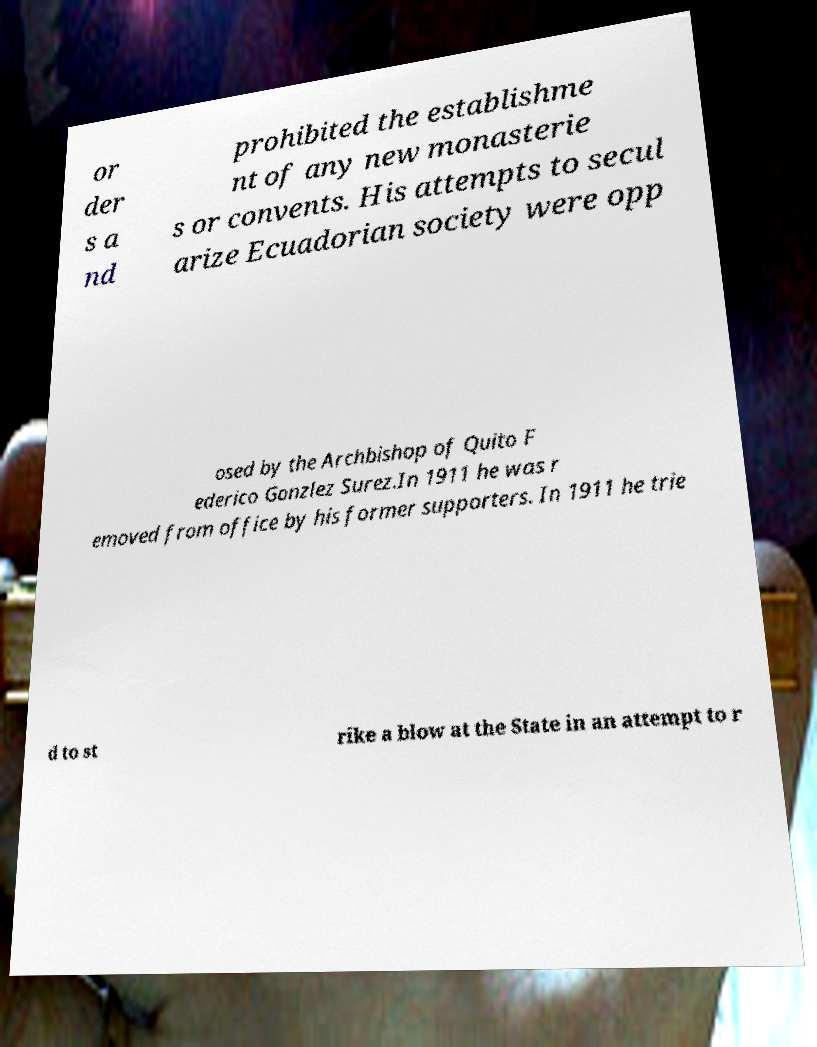What messages or text are displayed in this image? I need them in a readable, typed format. or der s a nd prohibited the establishme nt of any new monasterie s or convents. His attempts to secul arize Ecuadorian society were opp osed by the Archbishop of Quito F ederico Gonzlez Surez.In 1911 he was r emoved from office by his former supporters. In 1911 he trie d to st rike a blow at the State in an attempt to r 